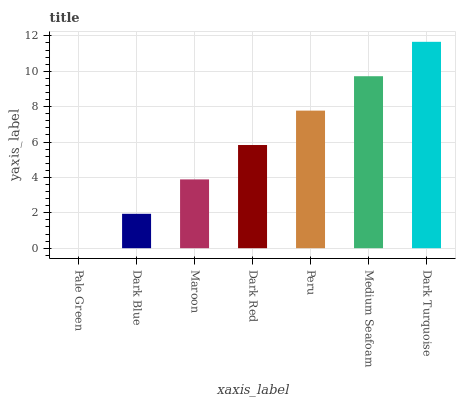Is Pale Green the minimum?
Answer yes or no. Yes. Is Dark Turquoise the maximum?
Answer yes or no. Yes. Is Dark Blue the minimum?
Answer yes or no. No. Is Dark Blue the maximum?
Answer yes or no. No. Is Dark Blue greater than Pale Green?
Answer yes or no. Yes. Is Pale Green less than Dark Blue?
Answer yes or no. Yes. Is Pale Green greater than Dark Blue?
Answer yes or no. No. Is Dark Blue less than Pale Green?
Answer yes or no. No. Is Dark Red the high median?
Answer yes or no. Yes. Is Dark Red the low median?
Answer yes or no. Yes. Is Dark Blue the high median?
Answer yes or no. No. Is Peru the low median?
Answer yes or no. No. 